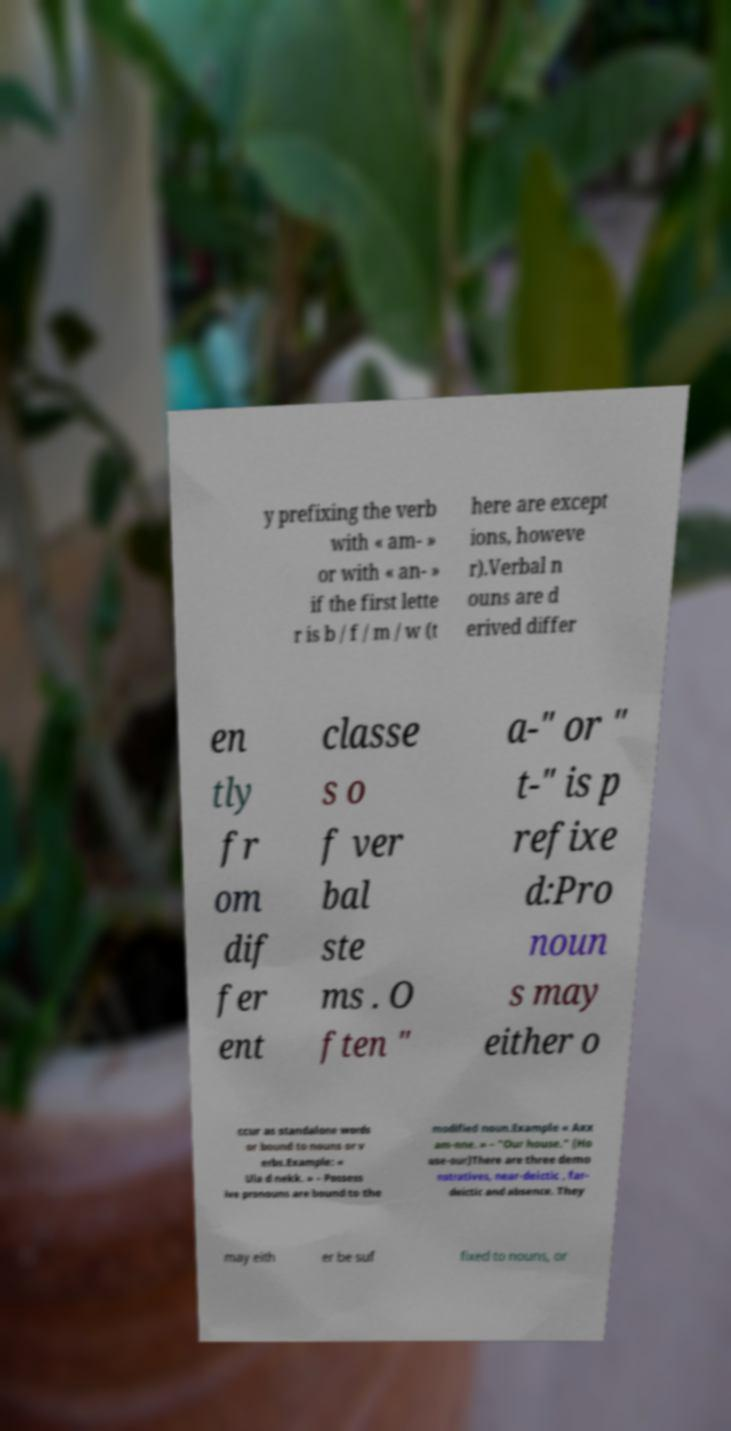Please identify and transcribe the text found in this image. y prefixing the verb with « am- » or with « an- » if the first lette r is b / f / m / w (t here are except ions, howeve r).Verbal n ouns are d erived differ en tly fr om dif fer ent classe s o f ver bal ste ms . O ften " a-" or " t-" is p refixe d:Pro noun s may either o ccur as standalone words or bound to nouns or v erbs.Example: « Ula d nekk. » – Possess ive pronouns are bound to the modified noun.Example « Axx am-nne. » – "Our house." (Ho use-our)There are three demo nstratives, near-deictic , far- deictic and absence. They may eith er be suf fixed to nouns, or 